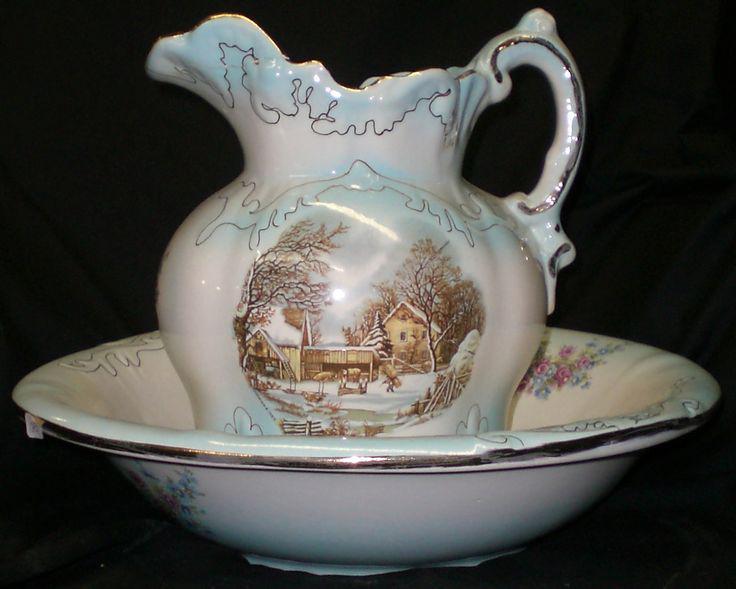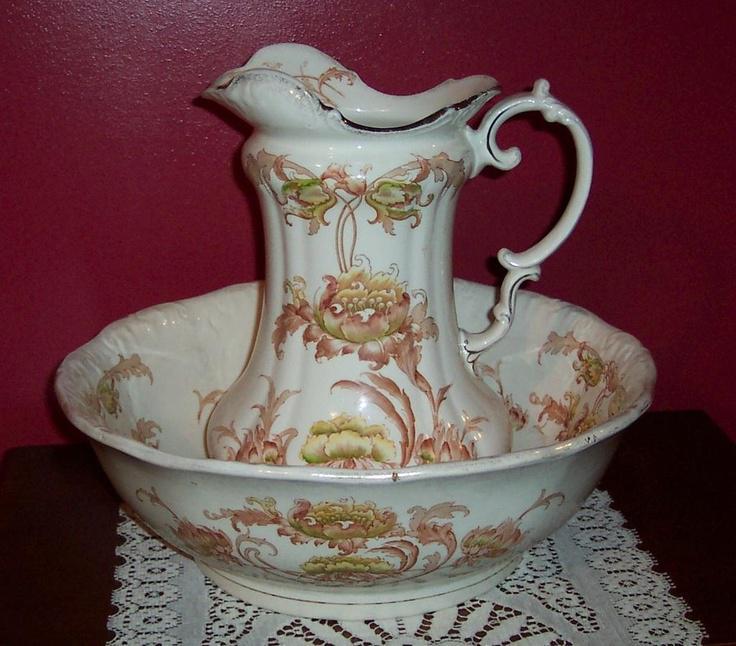The first image is the image on the left, the second image is the image on the right. For the images shown, is this caption "Both handles are on the right side." true? Answer yes or no. Yes. The first image is the image on the left, the second image is the image on the right. Given the left and right images, does the statement "The spout of every pitcher is facing to the left." hold true? Answer yes or no. Yes. 